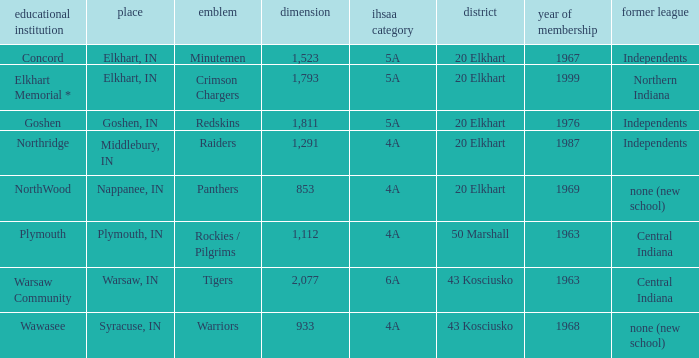What is the IHSAA class for the team located in Middlebury, IN? 4A. 